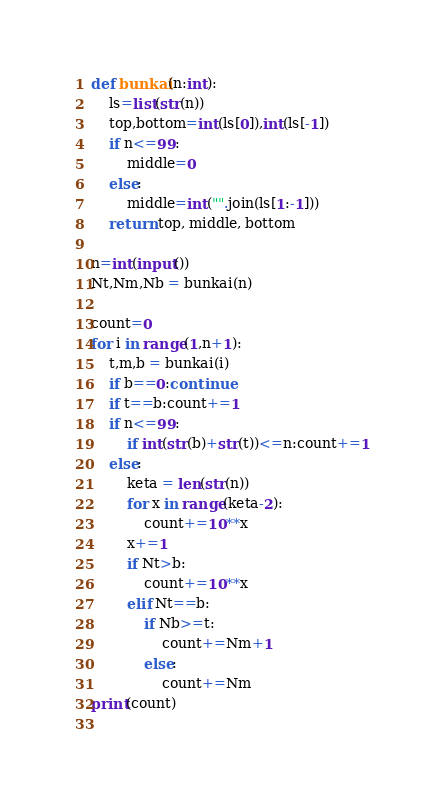Convert code to text. <code><loc_0><loc_0><loc_500><loc_500><_Python_>def bunkai(n:int):
    ls=list(str(n))
    top,bottom=int(ls[0]),int(ls[-1])
    if n<=99:
        middle=0
    else:
        middle=int("".join(ls[1:-1]))
    return top, middle, bottom

n=int(input())
Nt,Nm,Nb = bunkai(n)

count=0
for i in range(1,n+1):
    t,m,b = bunkai(i)
    if b==0:continue
    if t==b:count+=1
    if n<=99:
        if int(str(b)+str(t))<=n:count+=1
    else:
        keta = len(str(n))
        for x in range(keta-2):
            count+=10**x
        x+=1
        if Nt>b:
            count+=10**x
        elif Nt==b:
            if Nb>=t:
                count+=Nm+1
            else:
                count+=Nm
print(count)
    
</code> 